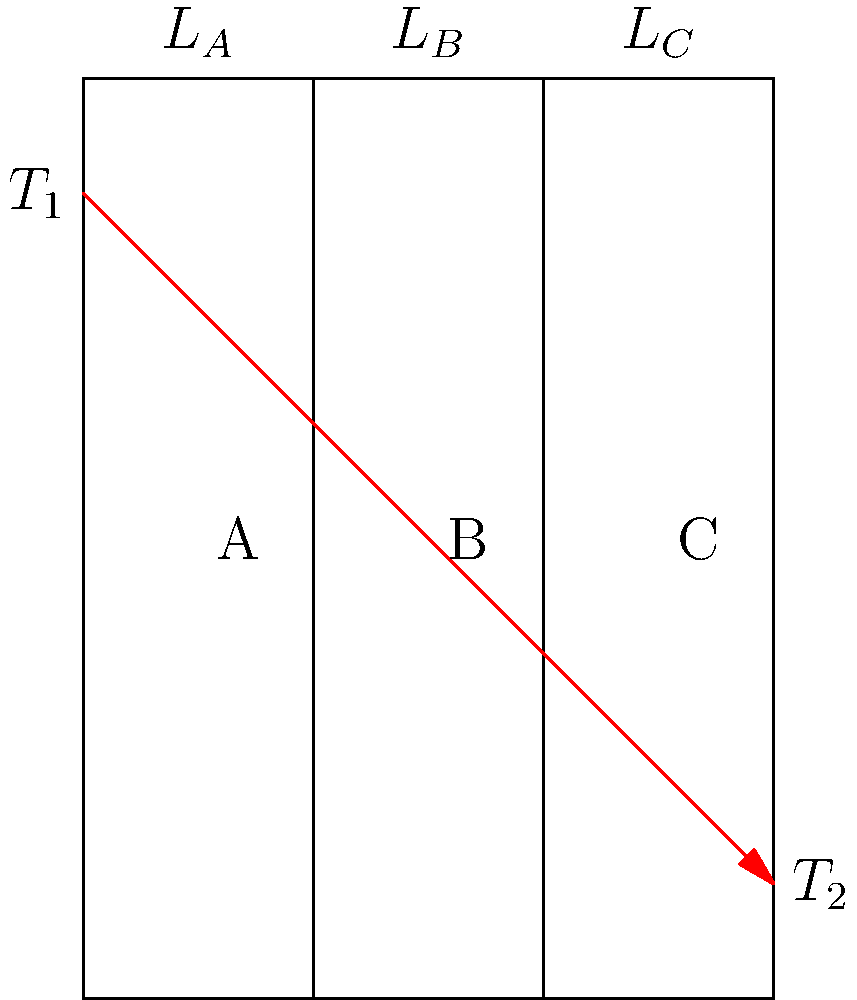In a legal case involving building energy efficiency standards, you encounter a composite wall consisting of three layers (A, B, and C) with thermal conductivities $k_A$, $k_B$, and $k_C$, and thicknesses $L_A$, $L_B$, and $L_C$, respectively. The temperature difference across the wall is $(T_1 - T_2)$. What is the expression for the total heat flux through this composite wall in terms of these variables? To determine the heat flux through the composite wall, we'll follow these steps:

1. Recall Fourier's law of heat conduction: $q = -k \frac{dT}{dx}$

2. For steady-state heat transfer, the heat flux is constant through all layers.

3. The total temperature difference is the sum of temperature differences across each layer:
   $$(T_1 - T_2) = (T_1 - T_A) + (T_A - T_B) + (T_B - T_2)$$

4. Apply Fourier's law to each layer:
   $$q = k_A \frac{T_1 - T_A}{L_A} = k_B \frac{T_A - T_B}{L_B} = k_C \frac{T_B - T_2}{L_C}$$

5. Express each temperature difference in terms of q:
   $$T_1 - T_A = \frac{qL_A}{k_A}, \quad T_A - T_B = \frac{qL_B}{k_B}, \quad T_B - T_2 = \frac{qL_C}{k_C}$$

6. Substitute these into the total temperature difference equation:
   $$T_1 - T_2 = \frac{qL_A}{k_A} + \frac{qL_B}{k_B} + \frac{qL_C}{k_C}$$

7. Factor out q:
   $$T_1 - T_2 = q(\frac{L_A}{k_A} + \frac{L_B}{k_B} + \frac{L_C}{k_C})$$

8. Solve for q:
   $$q = \frac{T_1 - T_2}{\frac{L_A}{k_A} + \frac{L_B}{k_B} + \frac{L_C}{k_C}}$$

This expression represents the total heat flux through the composite wall.
Answer: $q = \frac{T_1 - T_2}{\frac{L_A}{k_A} + \frac{L_B}{k_B} + \frac{L_C}{k_C}}$ 